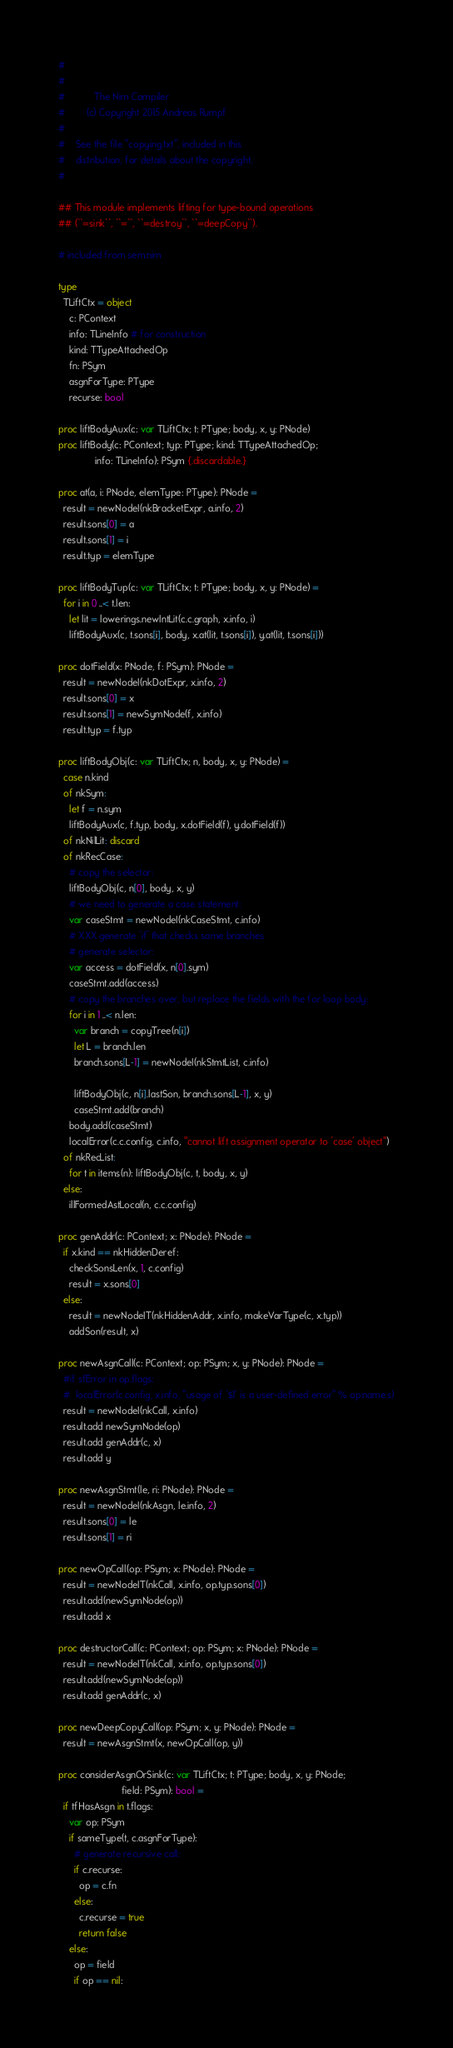<code> <loc_0><loc_0><loc_500><loc_500><_Nim_>#
#
#           The Nim Compiler
#        (c) Copyright 2015 Andreas Rumpf
#
#    See the file "copying.txt", included in this
#    distribution, for details about the copyright.
#

## This module implements lifting for type-bound operations
## (``=sink``, ``=``, ``=destroy``, ``=deepCopy``).

# included from sem.nim

type
  TLiftCtx = object
    c: PContext
    info: TLineInfo # for construction
    kind: TTypeAttachedOp
    fn: PSym
    asgnForType: PType
    recurse: bool

proc liftBodyAux(c: var TLiftCtx; t: PType; body, x, y: PNode)
proc liftBody(c: PContext; typ: PType; kind: TTypeAttachedOp;
              info: TLineInfo): PSym {.discardable.}

proc at(a, i: PNode, elemType: PType): PNode =
  result = newNodeI(nkBracketExpr, a.info, 2)
  result.sons[0] = a
  result.sons[1] = i
  result.typ = elemType

proc liftBodyTup(c: var TLiftCtx; t: PType; body, x, y: PNode) =
  for i in 0 ..< t.len:
    let lit = lowerings.newIntLit(c.c.graph, x.info, i)
    liftBodyAux(c, t.sons[i], body, x.at(lit, t.sons[i]), y.at(lit, t.sons[i]))

proc dotField(x: PNode, f: PSym): PNode =
  result = newNodeI(nkDotExpr, x.info, 2)
  result.sons[0] = x
  result.sons[1] = newSymNode(f, x.info)
  result.typ = f.typ

proc liftBodyObj(c: var TLiftCtx; n, body, x, y: PNode) =
  case n.kind
  of nkSym:
    let f = n.sym
    liftBodyAux(c, f.typ, body, x.dotField(f), y.dotField(f))
  of nkNilLit: discard
  of nkRecCase:
    # copy the selector:
    liftBodyObj(c, n[0], body, x, y)
    # we need to generate a case statement:
    var caseStmt = newNodeI(nkCaseStmt, c.info)
    # XXX generate 'if' that checks same branches
    # generate selector:
    var access = dotField(x, n[0].sym)
    caseStmt.add(access)
    # copy the branches over, but replace the fields with the for loop body:
    for i in 1 ..< n.len:
      var branch = copyTree(n[i])
      let L = branch.len
      branch.sons[L-1] = newNodeI(nkStmtList, c.info)

      liftBodyObj(c, n[i].lastSon, branch.sons[L-1], x, y)
      caseStmt.add(branch)
    body.add(caseStmt)
    localError(c.c.config, c.info, "cannot lift assignment operator to 'case' object")
  of nkRecList:
    for t in items(n): liftBodyObj(c, t, body, x, y)
  else:
    illFormedAstLocal(n, c.c.config)

proc genAddr(c: PContext; x: PNode): PNode =
  if x.kind == nkHiddenDeref:
    checkSonsLen(x, 1, c.config)
    result = x.sons[0]
  else:
    result = newNodeIT(nkHiddenAddr, x.info, makeVarType(c, x.typ))
    addSon(result, x)

proc newAsgnCall(c: PContext; op: PSym; x, y: PNode): PNode =
  #if sfError in op.flags:
  #  localError(c.config, x.info, "usage of '$1' is a user-defined error" % op.name.s)
  result = newNodeI(nkCall, x.info)
  result.add newSymNode(op)
  result.add genAddr(c, x)
  result.add y

proc newAsgnStmt(le, ri: PNode): PNode =
  result = newNodeI(nkAsgn, le.info, 2)
  result.sons[0] = le
  result.sons[1] = ri

proc newOpCall(op: PSym; x: PNode): PNode =
  result = newNodeIT(nkCall, x.info, op.typ.sons[0])
  result.add(newSymNode(op))
  result.add x

proc destructorCall(c: PContext; op: PSym; x: PNode): PNode =
  result = newNodeIT(nkCall, x.info, op.typ.sons[0])
  result.add(newSymNode(op))
  result.add genAddr(c, x)

proc newDeepCopyCall(op: PSym; x, y: PNode): PNode =
  result = newAsgnStmt(x, newOpCall(op, y))

proc considerAsgnOrSink(c: var TLiftCtx; t: PType; body, x, y: PNode;
                        field: PSym): bool =
  if tfHasAsgn in t.flags:
    var op: PSym
    if sameType(t, c.asgnForType):
      # generate recursive call:
      if c.recurse:
        op = c.fn
      else:
        c.recurse = true
        return false
    else:
      op = field
      if op == nil:</code> 